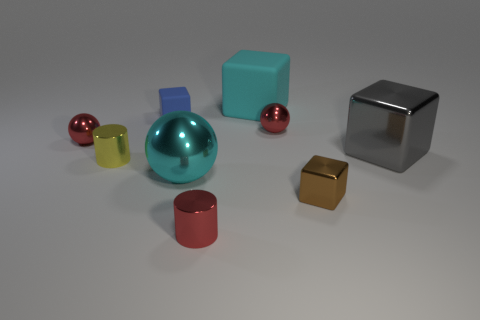Is the cylinder that is right of the tiny blue rubber cube made of the same material as the cyan block?
Ensure brevity in your answer.  No. How many small things are either red balls or cyan matte cubes?
Ensure brevity in your answer.  2. The cyan matte object has what size?
Offer a terse response. Large. Do the blue rubber cube and the metallic cylinder in front of the cyan ball have the same size?
Your response must be concise. Yes. How many brown objects are either large rubber things or balls?
Keep it short and to the point. 0. How many large blocks are there?
Offer a very short reply. 2. There is a ball in front of the gray shiny thing; what size is it?
Provide a short and direct response. Large. Does the red cylinder have the same size as the yellow metal cylinder?
Offer a terse response. Yes. What number of things are shiny cylinders or things behind the blue matte thing?
Offer a very short reply. 3. What is the tiny blue block made of?
Your answer should be very brief. Rubber. 